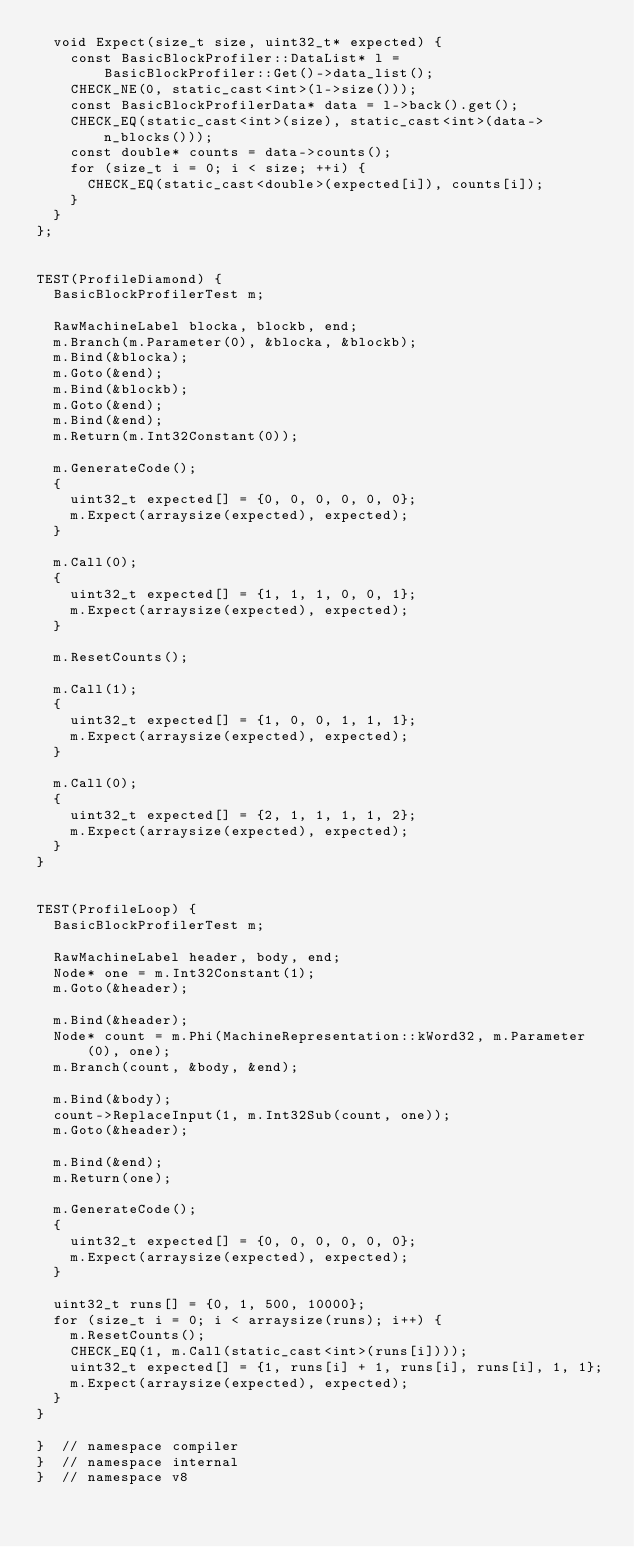Convert code to text. <code><loc_0><loc_0><loc_500><loc_500><_C++_>  void Expect(size_t size, uint32_t* expected) {
    const BasicBlockProfiler::DataList* l =
        BasicBlockProfiler::Get()->data_list();
    CHECK_NE(0, static_cast<int>(l->size()));
    const BasicBlockProfilerData* data = l->back().get();
    CHECK_EQ(static_cast<int>(size), static_cast<int>(data->n_blocks()));
    const double* counts = data->counts();
    for (size_t i = 0; i < size; ++i) {
      CHECK_EQ(static_cast<double>(expected[i]), counts[i]);
    }
  }
};


TEST(ProfileDiamond) {
  BasicBlockProfilerTest m;

  RawMachineLabel blocka, blockb, end;
  m.Branch(m.Parameter(0), &blocka, &blockb);
  m.Bind(&blocka);
  m.Goto(&end);
  m.Bind(&blockb);
  m.Goto(&end);
  m.Bind(&end);
  m.Return(m.Int32Constant(0));

  m.GenerateCode();
  {
    uint32_t expected[] = {0, 0, 0, 0, 0, 0};
    m.Expect(arraysize(expected), expected);
  }

  m.Call(0);
  {
    uint32_t expected[] = {1, 1, 1, 0, 0, 1};
    m.Expect(arraysize(expected), expected);
  }

  m.ResetCounts();

  m.Call(1);
  {
    uint32_t expected[] = {1, 0, 0, 1, 1, 1};
    m.Expect(arraysize(expected), expected);
  }

  m.Call(0);
  {
    uint32_t expected[] = {2, 1, 1, 1, 1, 2};
    m.Expect(arraysize(expected), expected);
  }
}


TEST(ProfileLoop) {
  BasicBlockProfilerTest m;

  RawMachineLabel header, body, end;
  Node* one = m.Int32Constant(1);
  m.Goto(&header);

  m.Bind(&header);
  Node* count = m.Phi(MachineRepresentation::kWord32, m.Parameter(0), one);
  m.Branch(count, &body, &end);

  m.Bind(&body);
  count->ReplaceInput(1, m.Int32Sub(count, one));
  m.Goto(&header);

  m.Bind(&end);
  m.Return(one);

  m.GenerateCode();
  {
    uint32_t expected[] = {0, 0, 0, 0, 0, 0};
    m.Expect(arraysize(expected), expected);
  }

  uint32_t runs[] = {0, 1, 500, 10000};
  for (size_t i = 0; i < arraysize(runs); i++) {
    m.ResetCounts();
    CHECK_EQ(1, m.Call(static_cast<int>(runs[i])));
    uint32_t expected[] = {1, runs[i] + 1, runs[i], runs[i], 1, 1};
    m.Expect(arraysize(expected), expected);
  }
}

}  // namespace compiler
}  // namespace internal
}  // namespace v8
</code> 